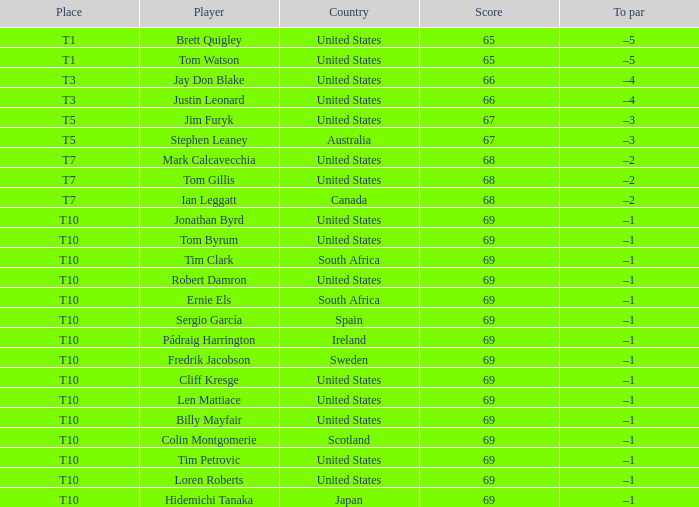Which country has is Len Mattiace in T10 place? United States. 